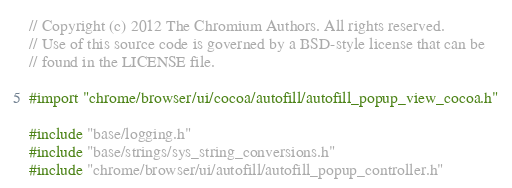<code> <loc_0><loc_0><loc_500><loc_500><_ObjectiveC_>// Copyright (c) 2012 The Chromium Authors. All rights reserved.
// Use of this source code is governed by a BSD-style license that can be
// found in the LICENSE file.

#import "chrome/browser/ui/cocoa/autofill/autofill_popup_view_cocoa.h"

#include "base/logging.h"
#include "base/strings/sys_string_conversions.h"
#include "chrome/browser/ui/autofill/autofill_popup_controller.h"</code> 